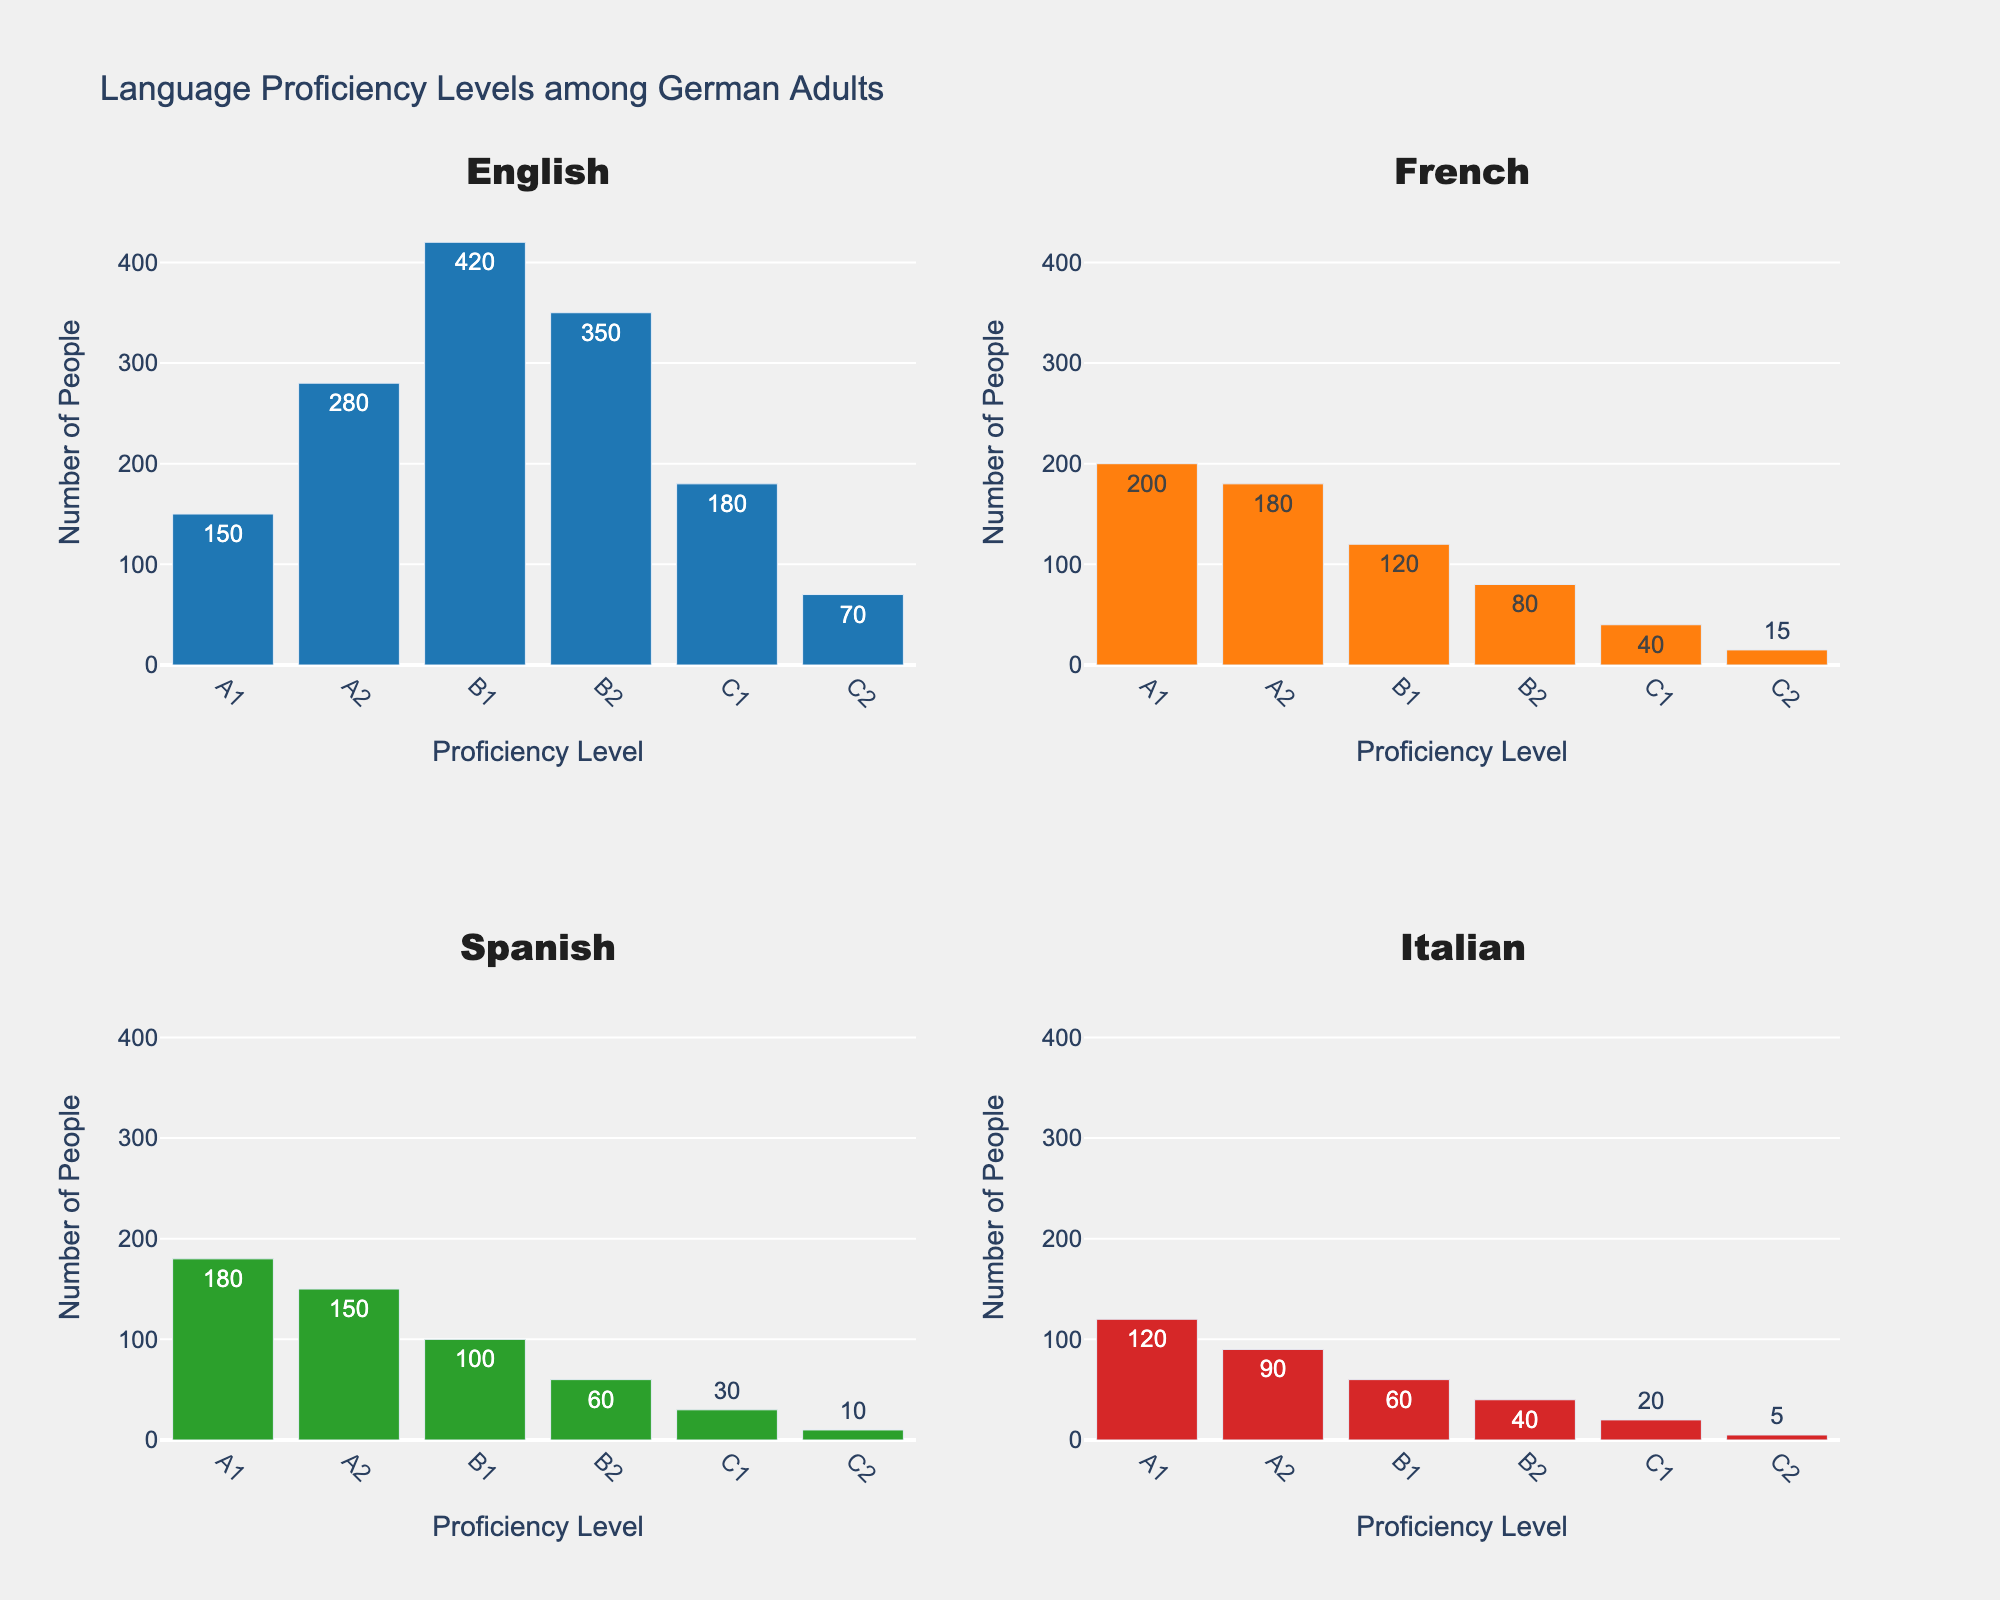What are the proficiency levels displayed in the histograms? The proficiency levels are displayed on the x-axis of each subplot, with categories A1, A2, B1, B2, C1, and C2.
Answer: A1, A2, B1, B2, C1, C2 Which language has the highest number of people at the A2 level? By observing the y-axis values for each language at the A2 level in the subplots, English has the highest bar indicating the count.
Answer: English What is the total number of people proficient in French? Summing the counts for each proficiency level in the French histogram: 200 + 180 + 120 + 80 + 40 + 15 = 635.
Answer: 635 Between Spanish and Italian, which language has more people at the B2 level? Comparing the heights of the B2 bars for Spanish and Italian in their respective subplots shows that Spanish has more people.
Answer: Spanish What is the average number of people for C1 proficiency across all languages? Adding the counts for C1 across all languages and dividing by the number of languages: (180 + 40 + 30 + 20) / 4 = 67.5.
Answer: 67.5 Which proficiency level has the lowest number of people for Italian? Observing the Italian histogram, the C2 level has the shortest bar indicating the lowest count.
Answer: C2 Comparing English and French, which language has a greater number of people at the B1 level? Checking the B1 bars for both languages shows that English has a taller bar than French.
Answer: English What is the difference in the number of people at the C2 and C1 levels for Spanish? Subtracting the counts for C2 and C1 levels in the Spanish histogram: 30 - 10 = 20.
Answer: 20 Which language has the most people in the B2 category? By looking at the B2 bars across all subplots, English has the longest bar for this category.
Answer: English Is the number of people with A1 proficiency greater in French or Spanish? Comparing the heights of the A1 bars for French and Spanish, French has a higher count.
Answer: French 